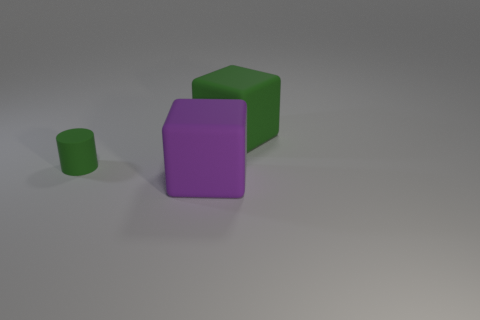Are there any other things that are the same size as the rubber cylinder?
Ensure brevity in your answer.  No. Is there any other thing that is the same shape as the large purple thing?
Provide a succinct answer. Yes. Are there more big purple matte objects that are in front of the green cylinder than large objects that are to the left of the big purple rubber object?
Ensure brevity in your answer.  Yes. What is the size of the green thing on the right side of the big object in front of the block that is behind the purple rubber thing?
Give a very brief answer. Large. Is the material of the small green cylinder the same as the large cube in front of the big green block?
Provide a succinct answer. Yes. Is the shape of the big green object the same as the small green matte object?
Ensure brevity in your answer.  No. What number of other objects are there of the same material as the cylinder?
Give a very brief answer. 2. What number of big green rubber objects have the same shape as the large purple rubber thing?
Keep it short and to the point. 1. What is the color of the matte thing that is both to the left of the large green block and right of the small green cylinder?
Keep it short and to the point. Purple. How many small green balls are there?
Provide a short and direct response. 0. 